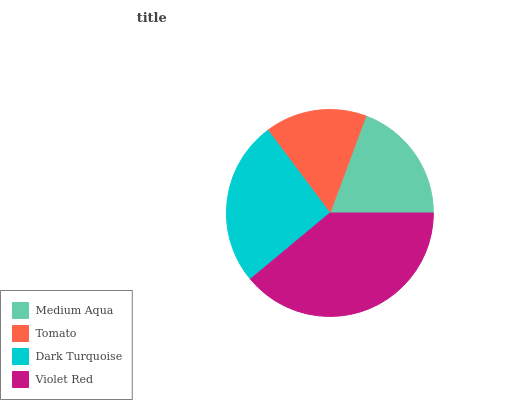Is Tomato the minimum?
Answer yes or no. Yes. Is Violet Red the maximum?
Answer yes or no. Yes. Is Dark Turquoise the minimum?
Answer yes or no. No. Is Dark Turquoise the maximum?
Answer yes or no. No. Is Dark Turquoise greater than Tomato?
Answer yes or no. Yes. Is Tomato less than Dark Turquoise?
Answer yes or no. Yes. Is Tomato greater than Dark Turquoise?
Answer yes or no. No. Is Dark Turquoise less than Tomato?
Answer yes or no. No. Is Dark Turquoise the high median?
Answer yes or no. Yes. Is Medium Aqua the low median?
Answer yes or no. Yes. Is Violet Red the high median?
Answer yes or no. No. Is Tomato the low median?
Answer yes or no. No. 